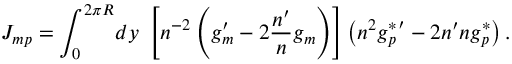Convert formula to latex. <formula><loc_0><loc_0><loc_500><loc_500>J _ { m p } = \int _ { 0 } ^ { 2 \pi R } \, d y \ \left [ n ^ { - 2 } \left ( g _ { m } ^ { \prime } - 2 \frac { n ^ { \prime } } { n } g _ { m } \right ) \right ] \left ( n ^ { 2 } { g _ { p } ^ { * } } ^ { \prime } - 2 n ^ { \prime } n g _ { p } ^ { * } \right ) .</formula> 